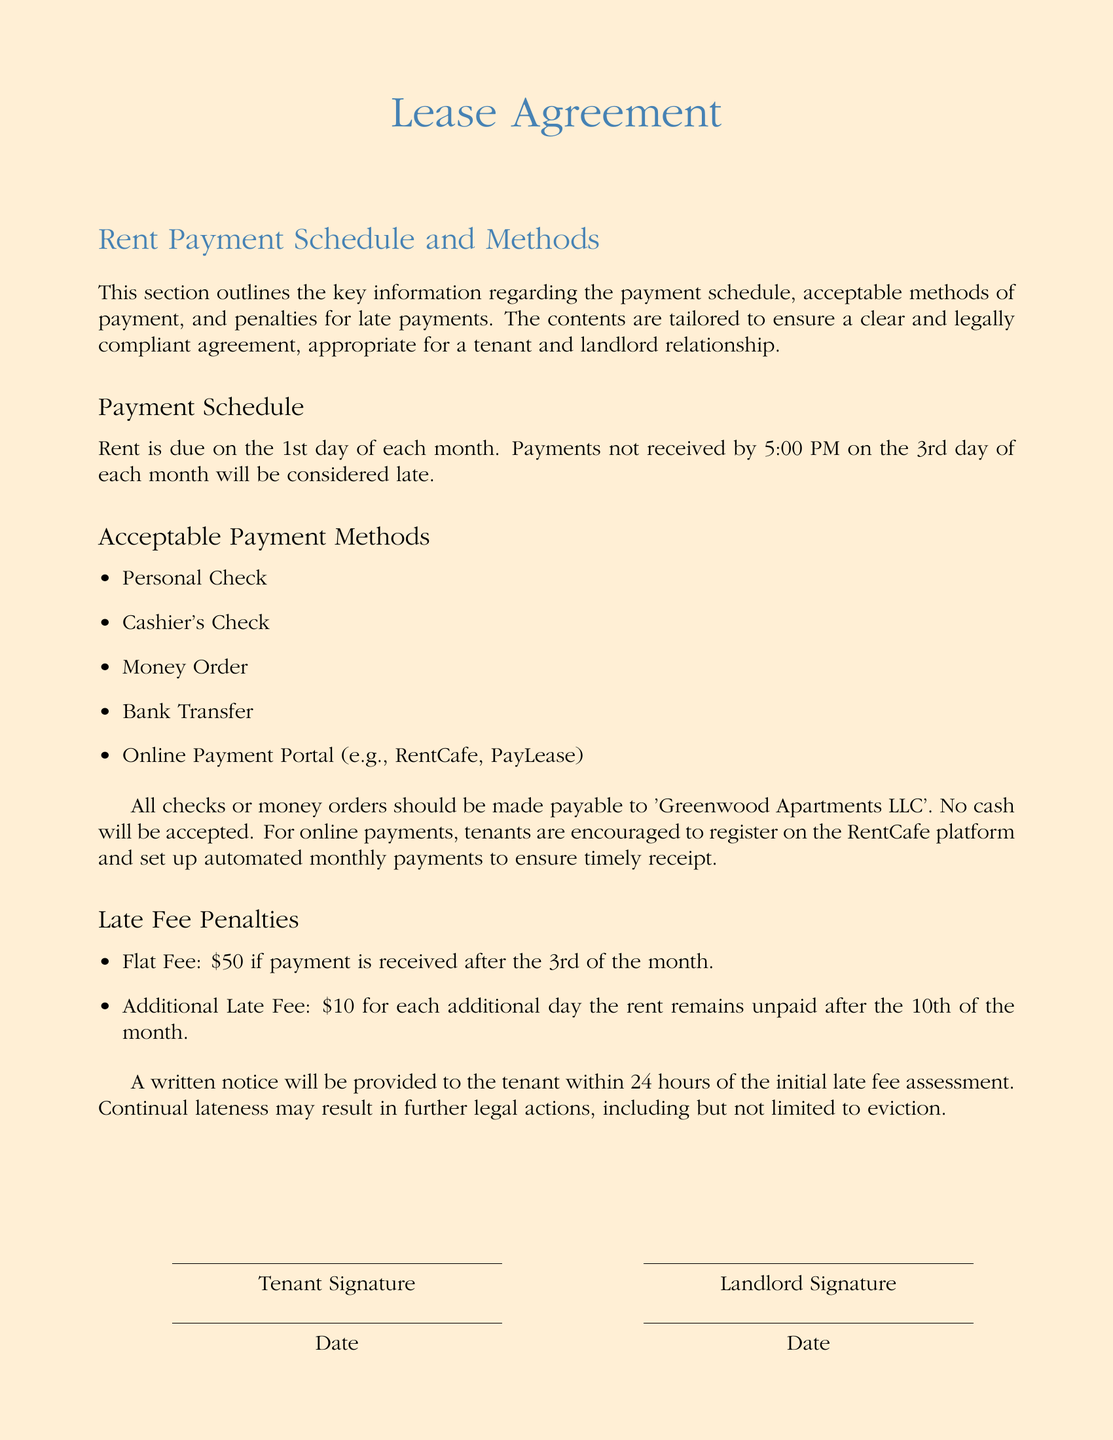What day is the rent due? The rent is due on the 1st day of each month.
Answer: 1st day What time is the payment considered late on the 3rd? Payments not received by 5:00 PM on the 3rd will be considered late.
Answer: 5:00 PM What is the flat fee for a late payment? The flat fee for a late payment is stated clearly in the document.
Answer: $50 Which payment method is not accepted? The document lists acceptable payment methods and specifies which is not allowed.
Answer: Cash What is the additional late fee after the 10th? The document outlines what happens for continual lateness and specifies an additional fee.
Answer: $10 Who should checks or money orders be payable to? This specifies the name that needs to be on the checks or money orders according to the document.
Answer: Greenwood Apartments LLC What percentage of tenants have encouraged automated payments? A suggestion is made regarding registrations for a payment platform, but no percentage is given.
Answer: N/A (not mentioned) What happens if continuous lateness occurs? The document details actions that may result from continual lateness indicating the possible outcomes.
Answer: Eviction 